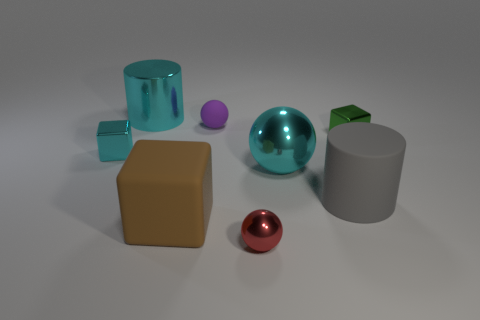What number of green metal cubes have the same size as the purple rubber sphere?
Your answer should be very brief. 1. Is the number of purple objects that are in front of the rubber cylinder greater than the number of big metal things in front of the green metallic cube?
Make the answer very short. No. The rubber thing behind the big cylinder that is in front of the rubber ball is what color?
Provide a succinct answer. Purple. Does the green cube have the same material as the big brown cube?
Keep it short and to the point. No. Are there any other objects of the same shape as the purple rubber object?
Your response must be concise. Yes. There is a tiny block that is right of the metallic cylinder; is it the same color as the rubber block?
Your response must be concise. No. There is a metallic block in front of the green shiny cube; is it the same size as the cube to the right of the big gray object?
Provide a succinct answer. Yes. There is a green block that is made of the same material as the large cyan ball; what is its size?
Give a very brief answer. Small. What number of cyan objects are to the left of the rubber cube and in front of the big cyan cylinder?
Provide a short and direct response. 1. What number of things are either tiny purple metallic objects or objects on the left side of the green metallic cube?
Offer a terse response. 7. 